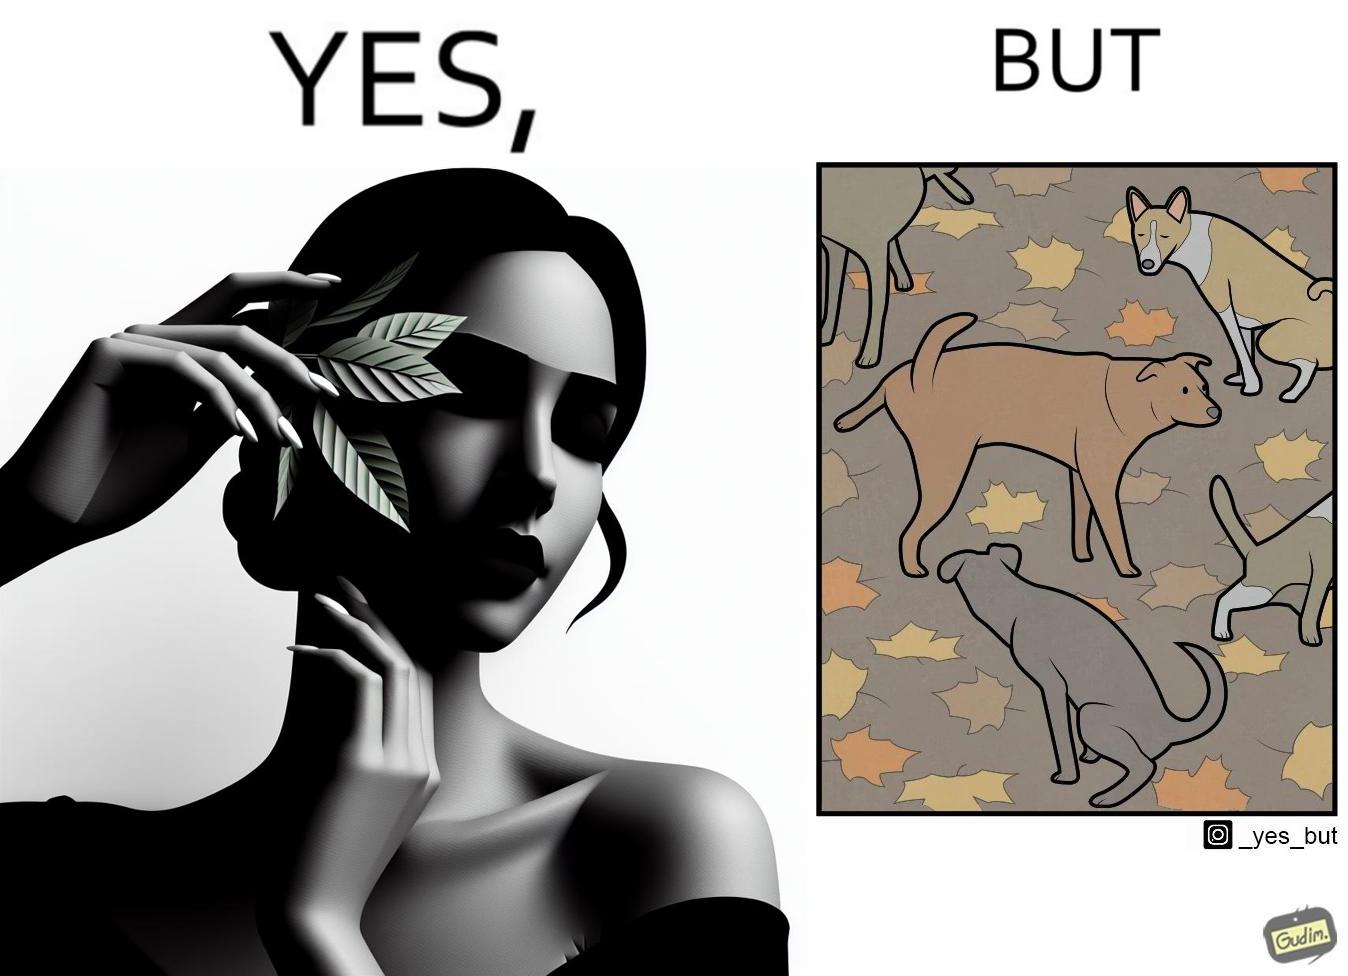Compare the left and right sides of this image. In the left part of the image: It is a woman holding a leaf over half of her face for a good photo In the right part of the image: It is a few dogs defecating and urinating over leaves 